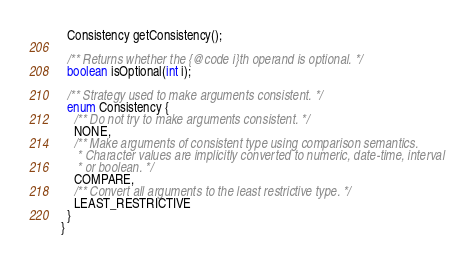Convert code to text. <code><loc_0><loc_0><loc_500><loc_500><_Java_>  Consistency getConsistency();

  /** Returns whether the {@code i}th operand is optional. */
  boolean isOptional(int i);

  /** Strategy used to make arguments consistent. */
  enum Consistency {
    /** Do not try to make arguments consistent. */
    NONE,
    /** Make arguments of consistent type using comparison semantics.
     * Character values are implicitly converted to numeric, date-time, interval
     * or boolean. */
    COMPARE,
    /** Convert all arguments to the least restrictive type. */
    LEAST_RESTRICTIVE
  }
}
</code> 